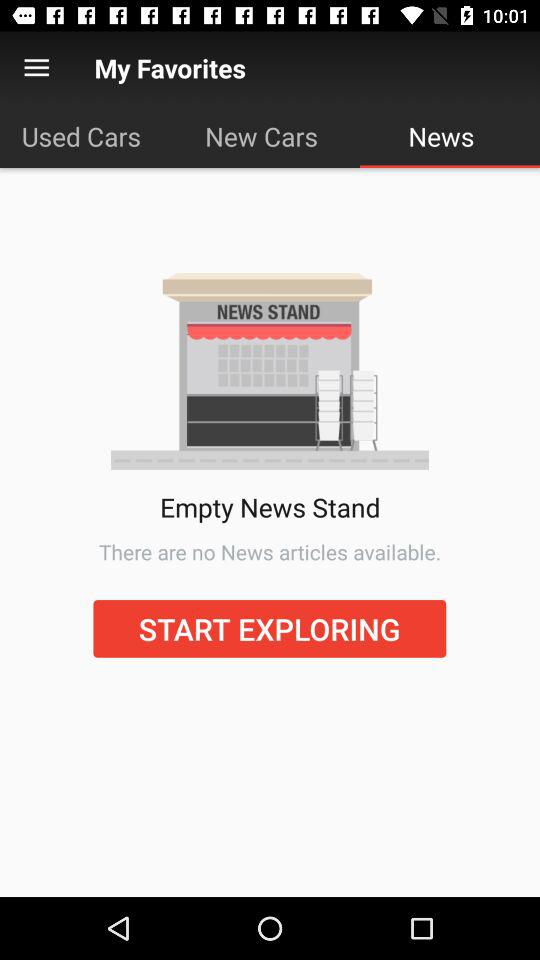When was the "New Cars" tab last updated?
When the provided information is insufficient, respond with <no answer>. <no answer> 